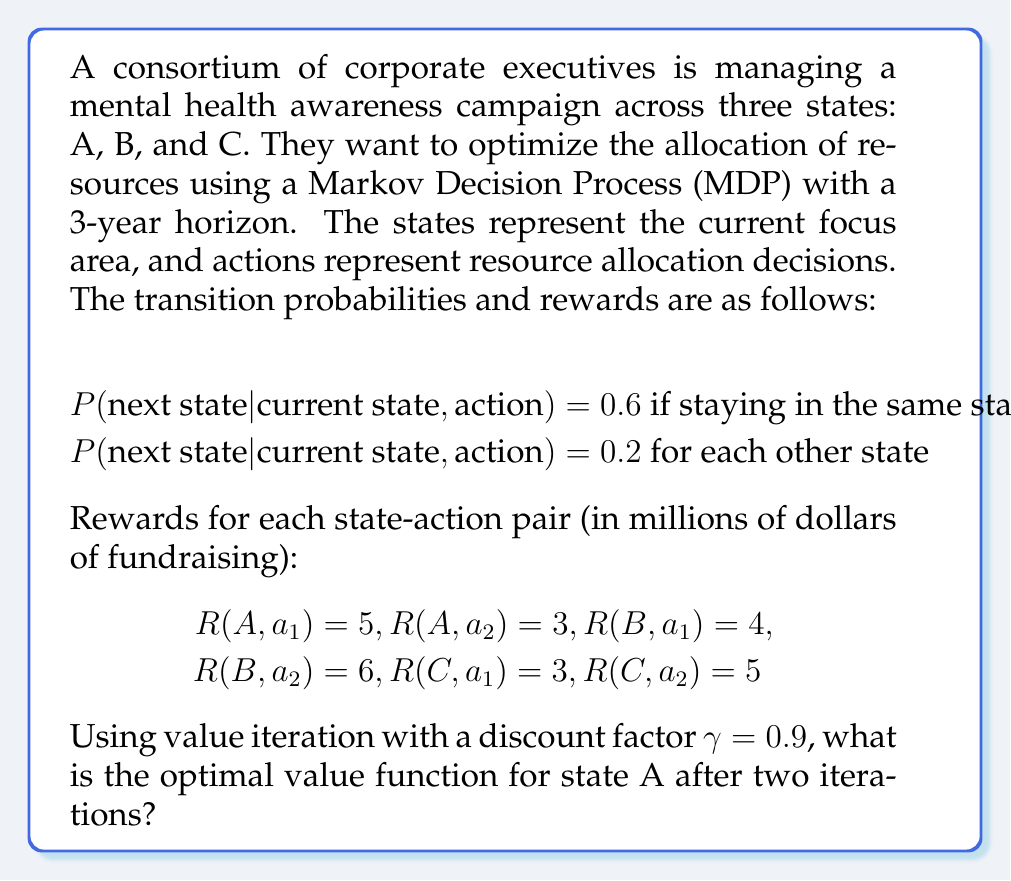Can you answer this question? Let's solve this step-by-step using value iteration:

1) Initialize the value function $V_0(s) = 0$ for all states s.

2) For the first iteration (k=1), we compute:

   $V_1(s) = \max_a [R(s,a) + \gamma \sum_{s'} P(s'|s,a)V_0(s')]$

   For state A:
   $V_1(A) = \max \{5 + 0.9(0.6 \cdot 0 + 0.2 \cdot 0 + 0.2 \cdot 0), 
                    3 + 0.9(0.6 \cdot 0 + 0.2 \cdot 0 + 0.2 \cdot 0)\}$
   $V_1(A) = \max \{5, 3\} = 5$

3) For the second iteration (k=2):

   $V_2(A) = \max \{5 + 0.9(0.6 \cdot 5 + 0.2 \cdot 5 + 0.2 \cdot 5), 
                    3 + 0.9(0.6 \cdot 5 + 0.2 \cdot 5 + 0.2 \cdot 5)\}$
   $V_2(A) = \max \{5 + 0.9 \cdot 5, 3 + 0.9 \cdot 5\}$
   $V_2(A) = \max \{9.5, 7.5\} = 9.5$

Thus, the optimal value function for state A after two iterations is 9.5.
Answer: 9.5 